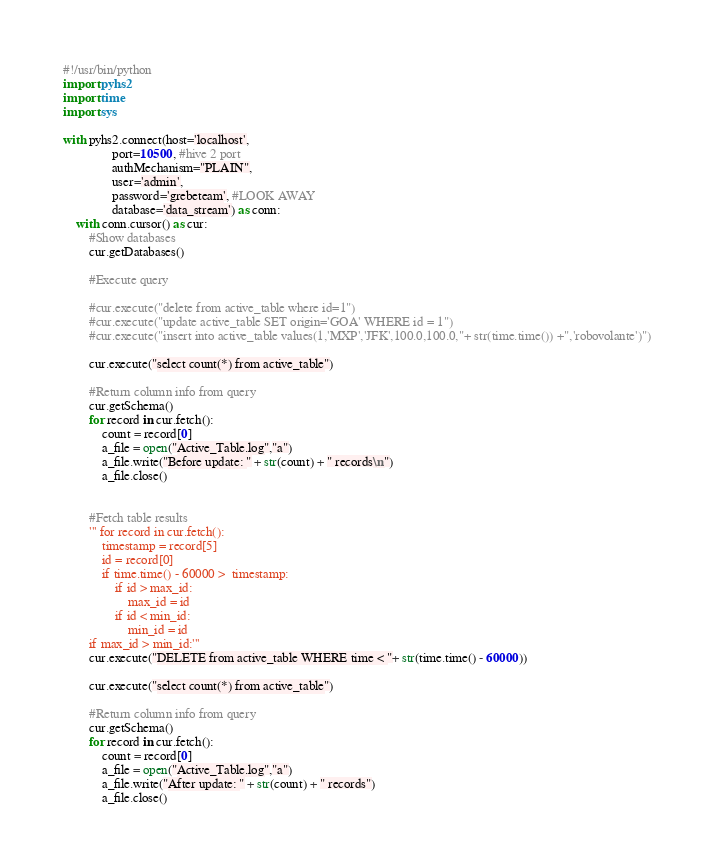Convert code to text. <code><loc_0><loc_0><loc_500><loc_500><_Python_>#!/usr/bin/python
import pyhs2
import time
import sys

with pyhs2.connect(host='localhost',
               port=10500, #hive 2 port
               authMechanism="PLAIN",
               user='admin',
               password='grebeteam', #LOOK AWAY
               database='data_stream') as conn:
    with conn.cursor() as cur:
        #Show databases
        cur.getDatabases()

        #Execute query
		
        #cur.execute("delete from active_table where id=1")
        #cur.execute("update active_table SET origin='GOA' WHERE id = 1")
        #cur.execute("insert into active_table values(1,'MXP','JFK',100.0,100.0,"+ str(time.time()) +",'robovolante')")
		
        cur.execute("select count(*) from active_table")
		
        #Return column info from query
        cur.getSchema()
        for record in cur.fetch():
            count = record[0]
            a_file = open("Active_Table.log","a")
            a_file.write("Before update: " + str(count) + " records\n")
            a_file.close()

		
        #Fetch table results
        ''' for record in cur.fetch():
            timestamp = record[5]
            id = record[0]
            if time.time() - 60000 >  timestamp:
                if id > max_id:
                    max_id = id
                if id < min_id:
                    min_id = id	
        if max_id > min_id:'''
        cur.execute("DELETE from active_table WHERE time < "+ str(time.time() - 60000))

        cur.execute("select count(*) from active_table")
		
        #Return column info from query
        cur.getSchema()
        for record in cur.fetch():
            count = record[0]
            a_file = open("Active_Table.log","a")
            a_file.write("After update: " + str(count) + " records")
            a_file.close()</code> 